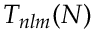Convert formula to latex. <formula><loc_0><loc_0><loc_500><loc_500>T _ { n l m } ( N )</formula> 